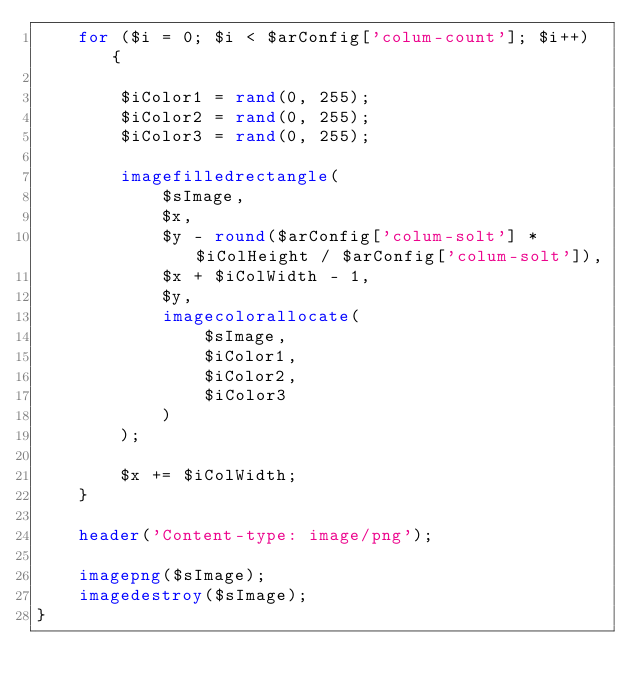Convert code to text. <code><loc_0><loc_0><loc_500><loc_500><_PHP_>    for ($i = 0; $i < $arConfig['colum-count']; $i++) {

        $iColor1 = rand(0, 255);
        $iColor2 = rand(0, 255);
        $iColor3 = rand(0, 255);

        imagefilledrectangle(
            $sImage,
            $x,
            $y - round($arConfig['colum-solt'] * $iColHeight / $arConfig['colum-solt']),
            $x + $iColWidth - 1,
            $y,
            imagecolorallocate(
                $sImage,
                $iColor1,
                $iColor2,
                $iColor3
            )
        );

        $x += $iColWidth;
    }

    header('Content-type: image/png');

    imagepng($sImage);
    imagedestroy($sImage);
}</code> 